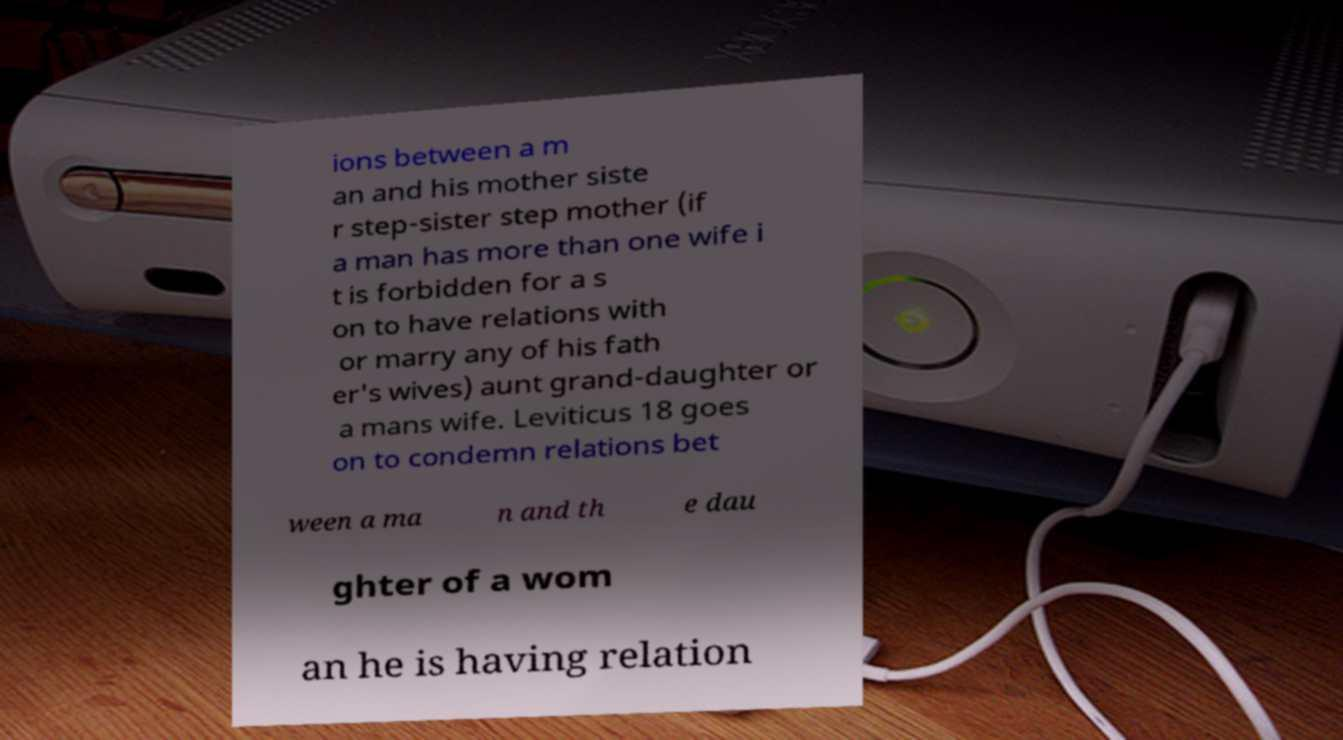Please read and relay the text visible in this image. What does it say? ions between a m an and his mother siste r step-sister step mother (if a man has more than one wife i t is forbidden for a s on to have relations with or marry any of his fath er's wives) aunt grand-daughter or a mans wife. Leviticus 18 goes on to condemn relations bet ween a ma n and th e dau ghter of a wom an he is having relation 